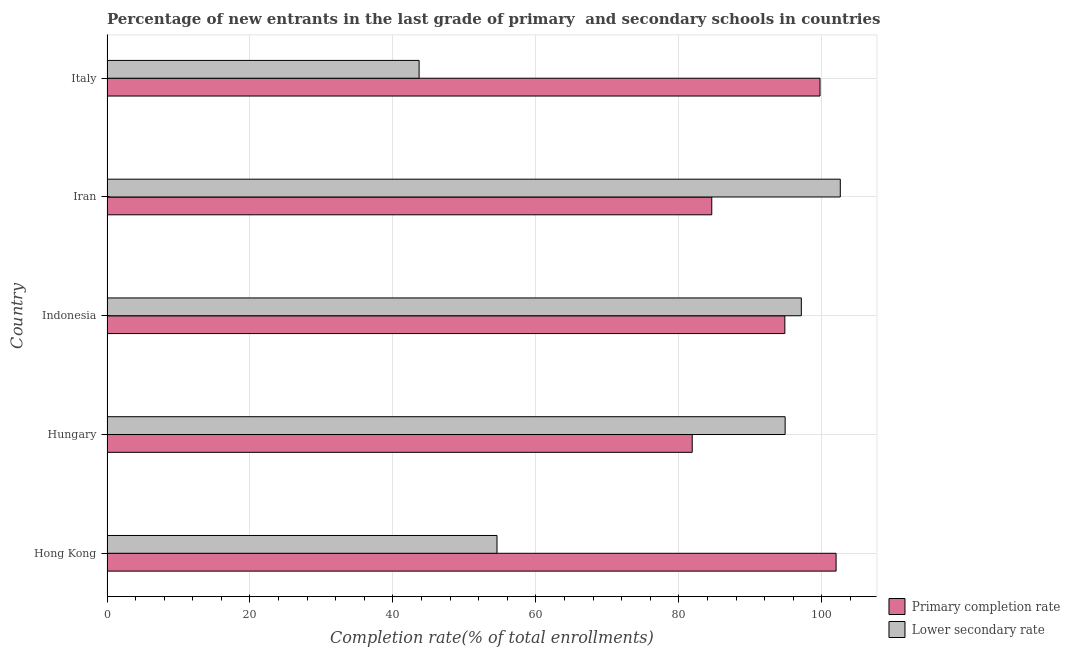Are the number of bars on each tick of the Y-axis equal?
Provide a succinct answer. Yes. What is the label of the 4th group of bars from the top?
Ensure brevity in your answer.  Hungary. What is the completion rate in primary schools in Italy?
Offer a terse response. 99.76. Across all countries, what is the maximum completion rate in primary schools?
Your answer should be compact. 102. Across all countries, what is the minimum completion rate in primary schools?
Your answer should be compact. 81.87. In which country was the completion rate in primary schools maximum?
Keep it short and to the point. Hong Kong. In which country was the completion rate in secondary schools minimum?
Give a very brief answer. Italy. What is the total completion rate in secondary schools in the graph?
Make the answer very short. 392.83. What is the difference between the completion rate in primary schools in Hungary and that in Iran?
Make the answer very short. -2.74. What is the difference between the completion rate in secondary schools in Hungary and the completion rate in primary schools in Indonesia?
Ensure brevity in your answer.  0.04. What is the average completion rate in primary schools per country?
Your answer should be compact. 92.61. What is the difference between the completion rate in primary schools and completion rate in secondary schools in Iran?
Ensure brevity in your answer.  -17.98. What is the ratio of the completion rate in secondary schools in Hungary to that in Italy?
Your answer should be compact. 2.17. What is the difference between the highest and the second highest completion rate in secondary schools?
Keep it short and to the point. 5.45. What is the difference between the highest and the lowest completion rate in secondary schools?
Keep it short and to the point. 58.93. What does the 2nd bar from the top in Indonesia represents?
Provide a short and direct response. Primary completion rate. What does the 1st bar from the bottom in Hungary represents?
Your answer should be compact. Primary completion rate. How many bars are there?
Provide a short and direct response. 10. Are all the bars in the graph horizontal?
Keep it short and to the point. Yes. How many countries are there in the graph?
Your response must be concise. 5. What is the difference between two consecutive major ticks on the X-axis?
Give a very brief answer. 20. Are the values on the major ticks of X-axis written in scientific E-notation?
Make the answer very short. No. Does the graph contain any zero values?
Keep it short and to the point. No. Where does the legend appear in the graph?
Give a very brief answer. Bottom right. How many legend labels are there?
Your response must be concise. 2. What is the title of the graph?
Provide a succinct answer. Percentage of new entrants in the last grade of primary  and secondary schools in countries. Does "Forest" appear as one of the legend labels in the graph?
Your answer should be compact. No. What is the label or title of the X-axis?
Your response must be concise. Completion rate(% of total enrollments). What is the Completion rate(% of total enrollments) of Primary completion rate in Hong Kong?
Your response must be concise. 102. What is the Completion rate(% of total enrollments) in Lower secondary rate in Hong Kong?
Give a very brief answer. 54.56. What is the Completion rate(% of total enrollments) in Primary completion rate in Hungary?
Offer a terse response. 81.87. What is the Completion rate(% of total enrollments) in Lower secondary rate in Hungary?
Give a very brief answer. 94.87. What is the Completion rate(% of total enrollments) of Primary completion rate in Indonesia?
Your answer should be very brief. 94.83. What is the Completion rate(% of total enrollments) of Lower secondary rate in Indonesia?
Your answer should be very brief. 97.14. What is the Completion rate(% of total enrollments) in Primary completion rate in Iran?
Ensure brevity in your answer.  84.61. What is the Completion rate(% of total enrollments) in Lower secondary rate in Iran?
Your answer should be compact. 102.59. What is the Completion rate(% of total enrollments) in Primary completion rate in Italy?
Provide a short and direct response. 99.76. What is the Completion rate(% of total enrollments) in Lower secondary rate in Italy?
Provide a short and direct response. 43.67. Across all countries, what is the maximum Completion rate(% of total enrollments) of Primary completion rate?
Your answer should be very brief. 102. Across all countries, what is the maximum Completion rate(% of total enrollments) of Lower secondary rate?
Make the answer very short. 102.59. Across all countries, what is the minimum Completion rate(% of total enrollments) of Primary completion rate?
Give a very brief answer. 81.87. Across all countries, what is the minimum Completion rate(% of total enrollments) in Lower secondary rate?
Offer a very short reply. 43.67. What is the total Completion rate(% of total enrollments) of Primary completion rate in the graph?
Ensure brevity in your answer.  463.08. What is the total Completion rate(% of total enrollments) in Lower secondary rate in the graph?
Your answer should be compact. 392.83. What is the difference between the Completion rate(% of total enrollments) of Primary completion rate in Hong Kong and that in Hungary?
Offer a very short reply. 20.13. What is the difference between the Completion rate(% of total enrollments) in Lower secondary rate in Hong Kong and that in Hungary?
Give a very brief answer. -40.31. What is the difference between the Completion rate(% of total enrollments) in Primary completion rate in Hong Kong and that in Indonesia?
Your response must be concise. 7.17. What is the difference between the Completion rate(% of total enrollments) of Lower secondary rate in Hong Kong and that in Indonesia?
Keep it short and to the point. -42.58. What is the difference between the Completion rate(% of total enrollments) of Primary completion rate in Hong Kong and that in Iran?
Provide a short and direct response. 17.39. What is the difference between the Completion rate(% of total enrollments) in Lower secondary rate in Hong Kong and that in Iran?
Your answer should be compact. -48.03. What is the difference between the Completion rate(% of total enrollments) in Primary completion rate in Hong Kong and that in Italy?
Your answer should be compact. 2.25. What is the difference between the Completion rate(% of total enrollments) in Lower secondary rate in Hong Kong and that in Italy?
Your response must be concise. 10.9. What is the difference between the Completion rate(% of total enrollments) of Primary completion rate in Hungary and that in Indonesia?
Make the answer very short. -12.96. What is the difference between the Completion rate(% of total enrollments) of Lower secondary rate in Hungary and that in Indonesia?
Your response must be concise. -2.26. What is the difference between the Completion rate(% of total enrollments) of Primary completion rate in Hungary and that in Iran?
Give a very brief answer. -2.74. What is the difference between the Completion rate(% of total enrollments) in Lower secondary rate in Hungary and that in Iran?
Your response must be concise. -7.72. What is the difference between the Completion rate(% of total enrollments) in Primary completion rate in Hungary and that in Italy?
Offer a very short reply. -17.88. What is the difference between the Completion rate(% of total enrollments) in Lower secondary rate in Hungary and that in Italy?
Offer a very short reply. 51.21. What is the difference between the Completion rate(% of total enrollments) of Primary completion rate in Indonesia and that in Iran?
Make the answer very short. 10.22. What is the difference between the Completion rate(% of total enrollments) of Lower secondary rate in Indonesia and that in Iran?
Your answer should be compact. -5.45. What is the difference between the Completion rate(% of total enrollments) in Primary completion rate in Indonesia and that in Italy?
Make the answer very short. -4.92. What is the difference between the Completion rate(% of total enrollments) in Lower secondary rate in Indonesia and that in Italy?
Provide a succinct answer. 53.47. What is the difference between the Completion rate(% of total enrollments) in Primary completion rate in Iran and that in Italy?
Your answer should be compact. -15.15. What is the difference between the Completion rate(% of total enrollments) of Lower secondary rate in Iran and that in Italy?
Make the answer very short. 58.93. What is the difference between the Completion rate(% of total enrollments) of Primary completion rate in Hong Kong and the Completion rate(% of total enrollments) of Lower secondary rate in Hungary?
Provide a succinct answer. 7.13. What is the difference between the Completion rate(% of total enrollments) of Primary completion rate in Hong Kong and the Completion rate(% of total enrollments) of Lower secondary rate in Indonesia?
Your answer should be very brief. 4.86. What is the difference between the Completion rate(% of total enrollments) in Primary completion rate in Hong Kong and the Completion rate(% of total enrollments) in Lower secondary rate in Iran?
Ensure brevity in your answer.  -0.59. What is the difference between the Completion rate(% of total enrollments) of Primary completion rate in Hong Kong and the Completion rate(% of total enrollments) of Lower secondary rate in Italy?
Offer a terse response. 58.34. What is the difference between the Completion rate(% of total enrollments) in Primary completion rate in Hungary and the Completion rate(% of total enrollments) in Lower secondary rate in Indonesia?
Provide a short and direct response. -15.26. What is the difference between the Completion rate(% of total enrollments) in Primary completion rate in Hungary and the Completion rate(% of total enrollments) in Lower secondary rate in Iran?
Keep it short and to the point. -20.72. What is the difference between the Completion rate(% of total enrollments) of Primary completion rate in Hungary and the Completion rate(% of total enrollments) of Lower secondary rate in Italy?
Offer a very short reply. 38.21. What is the difference between the Completion rate(% of total enrollments) in Primary completion rate in Indonesia and the Completion rate(% of total enrollments) in Lower secondary rate in Iran?
Your answer should be compact. -7.76. What is the difference between the Completion rate(% of total enrollments) of Primary completion rate in Indonesia and the Completion rate(% of total enrollments) of Lower secondary rate in Italy?
Provide a short and direct response. 51.17. What is the difference between the Completion rate(% of total enrollments) in Primary completion rate in Iran and the Completion rate(% of total enrollments) in Lower secondary rate in Italy?
Give a very brief answer. 40.94. What is the average Completion rate(% of total enrollments) in Primary completion rate per country?
Provide a short and direct response. 92.62. What is the average Completion rate(% of total enrollments) in Lower secondary rate per country?
Your answer should be very brief. 78.57. What is the difference between the Completion rate(% of total enrollments) of Primary completion rate and Completion rate(% of total enrollments) of Lower secondary rate in Hong Kong?
Make the answer very short. 47.44. What is the difference between the Completion rate(% of total enrollments) of Primary completion rate and Completion rate(% of total enrollments) of Lower secondary rate in Hungary?
Your answer should be compact. -13. What is the difference between the Completion rate(% of total enrollments) in Primary completion rate and Completion rate(% of total enrollments) in Lower secondary rate in Indonesia?
Your response must be concise. -2.31. What is the difference between the Completion rate(% of total enrollments) of Primary completion rate and Completion rate(% of total enrollments) of Lower secondary rate in Iran?
Provide a short and direct response. -17.98. What is the difference between the Completion rate(% of total enrollments) of Primary completion rate and Completion rate(% of total enrollments) of Lower secondary rate in Italy?
Make the answer very short. 56.09. What is the ratio of the Completion rate(% of total enrollments) of Primary completion rate in Hong Kong to that in Hungary?
Offer a terse response. 1.25. What is the ratio of the Completion rate(% of total enrollments) of Lower secondary rate in Hong Kong to that in Hungary?
Offer a very short reply. 0.58. What is the ratio of the Completion rate(% of total enrollments) of Primary completion rate in Hong Kong to that in Indonesia?
Provide a succinct answer. 1.08. What is the ratio of the Completion rate(% of total enrollments) in Lower secondary rate in Hong Kong to that in Indonesia?
Offer a very short reply. 0.56. What is the ratio of the Completion rate(% of total enrollments) of Primary completion rate in Hong Kong to that in Iran?
Keep it short and to the point. 1.21. What is the ratio of the Completion rate(% of total enrollments) in Lower secondary rate in Hong Kong to that in Iran?
Give a very brief answer. 0.53. What is the ratio of the Completion rate(% of total enrollments) in Primary completion rate in Hong Kong to that in Italy?
Offer a very short reply. 1.02. What is the ratio of the Completion rate(% of total enrollments) of Lower secondary rate in Hong Kong to that in Italy?
Provide a succinct answer. 1.25. What is the ratio of the Completion rate(% of total enrollments) of Primary completion rate in Hungary to that in Indonesia?
Give a very brief answer. 0.86. What is the ratio of the Completion rate(% of total enrollments) of Lower secondary rate in Hungary to that in Indonesia?
Provide a succinct answer. 0.98. What is the ratio of the Completion rate(% of total enrollments) of Lower secondary rate in Hungary to that in Iran?
Keep it short and to the point. 0.92. What is the ratio of the Completion rate(% of total enrollments) of Primary completion rate in Hungary to that in Italy?
Offer a very short reply. 0.82. What is the ratio of the Completion rate(% of total enrollments) in Lower secondary rate in Hungary to that in Italy?
Your answer should be very brief. 2.17. What is the ratio of the Completion rate(% of total enrollments) of Primary completion rate in Indonesia to that in Iran?
Provide a succinct answer. 1.12. What is the ratio of the Completion rate(% of total enrollments) of Lower secondary rate in Indonesia to that in Iran?
Give a very brief answer. 0.95. What is the ratio of the Completion rate(% of total enrollments) of Primary completion rate in Indonesia to that in Italy?
Offer a terse response. 0.95. What is the ratio of the Completion rate(% of total enrollments) of Lower secondary rate in Indonesia to that in Italy?
Provide a short and direct response. 2.22. What is the ratio of the Completion rate(% of total enrollments) in Primary completion rate in Iran to that in Italy?
Give a very brief answer. 0.85. What is the ratio of the Completion rate(% of total enrollments) in Lower secondary rate in Iran to that in Italy?
Make the answer very short. 2.35. What is the difference between the highest and the second highest Completion rate(% of total enrollments) in Primary completion rate?
Keep it short and to the point. 2.25. What is the difference between the highest and the second highest Completion rate(% of total enrollments) of Lower secondary rate?
Make the answer very short. 5.45. What is the difference between the highest and the lowest Completion rate(% of total enrollments) of Primary completion rate?
Your answer should be very brief. 20.13. What is the difference between the highest and the lowest Completion rate(% of total enrollments) of Lower secondary rate?
Give a very brief answer. 58.93. 